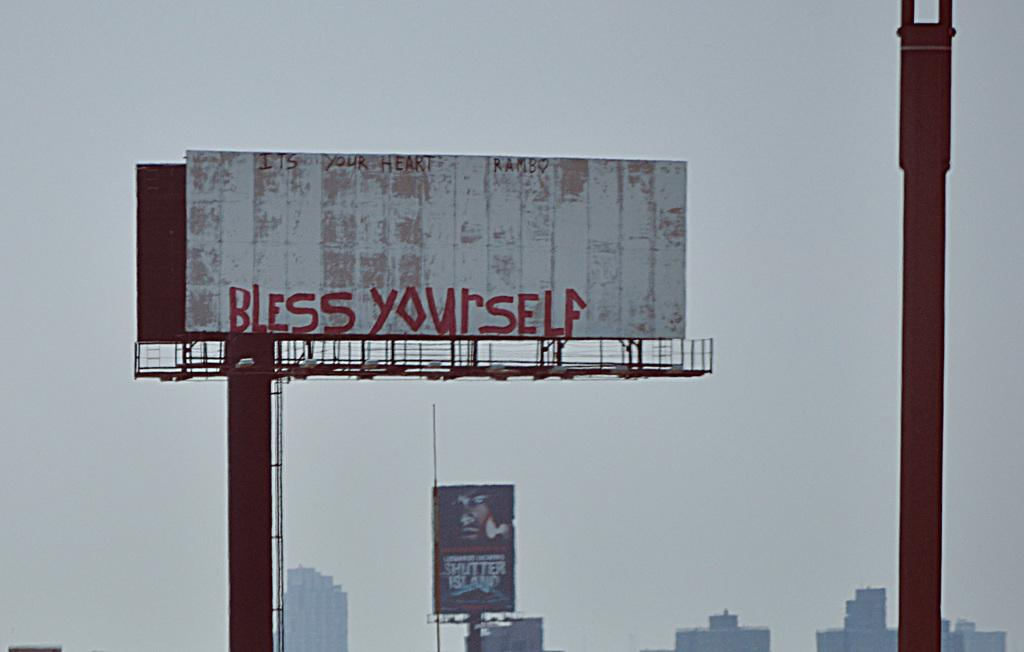<image>
Render a clear and concise summary of the photo. A tall billboard that has no advertisement on it but someone has written Bless Yourself in red. 